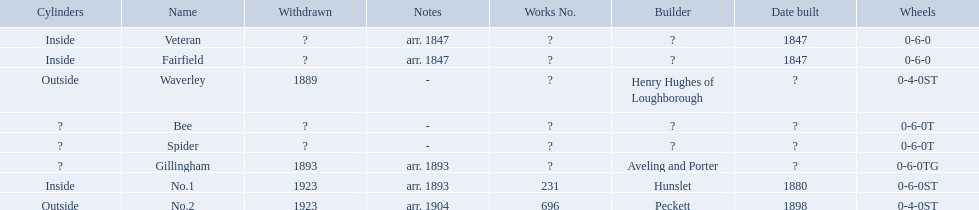What are the alderney railway names? Veteran, Fairfield, Waverley, Bee, Spider, Gillingham, No.1, No.2. When was the farfield built? 1847. What else was built that year? Veteran. 